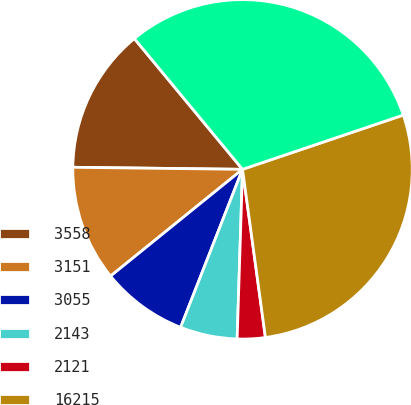<chart> <loc_0><loc_0><loc_500><loc_500><pie_chart><fcel>3558<fcel>3151<fcel>3055<fcel>2143<fcel>2121<fcel>16215<fcel>17369<nl><fcel>13.81%<fcel>11.02%<fcel>8.23%<fcel>5.44%<fcel>2.66%<fcel>28.03%<fcel>30.82%<nl></chart> 